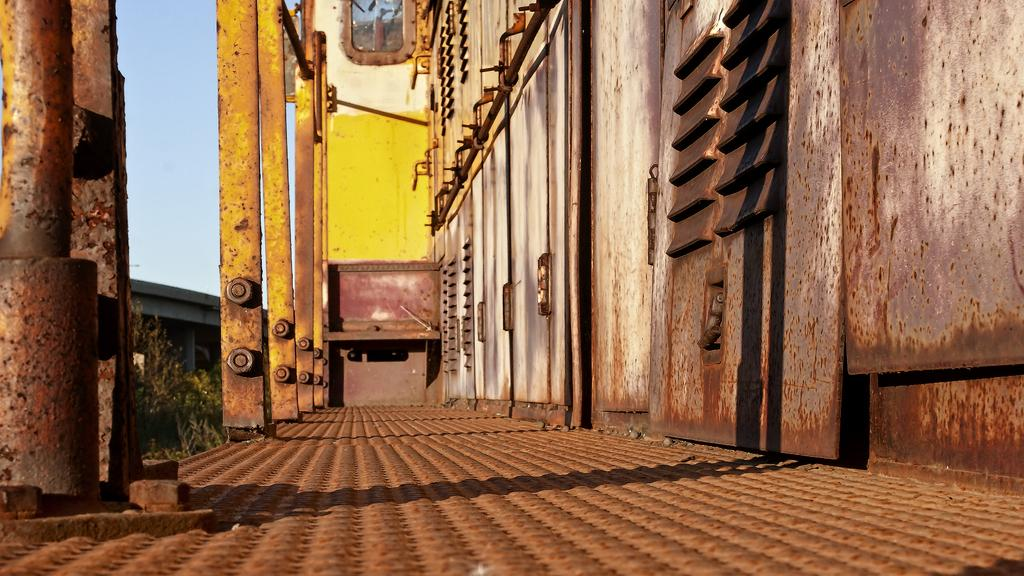What type of objects can be seen on the right side of the image? There are metal objects on the right side of the image. What is visible beneath the metal objects? The ground is visible in the image. What structures are present in the image? There are poles and a bridge in the image. What type of vegetation is present in the image? There are plants in the image. What part of the natural environment is visible in the image? The sky is visible in the image. Can you tell me how many times the cork pops up in the image? There is no cork present in the image. What emotion is the judge displaying in the image? There is no judge present in the image. 